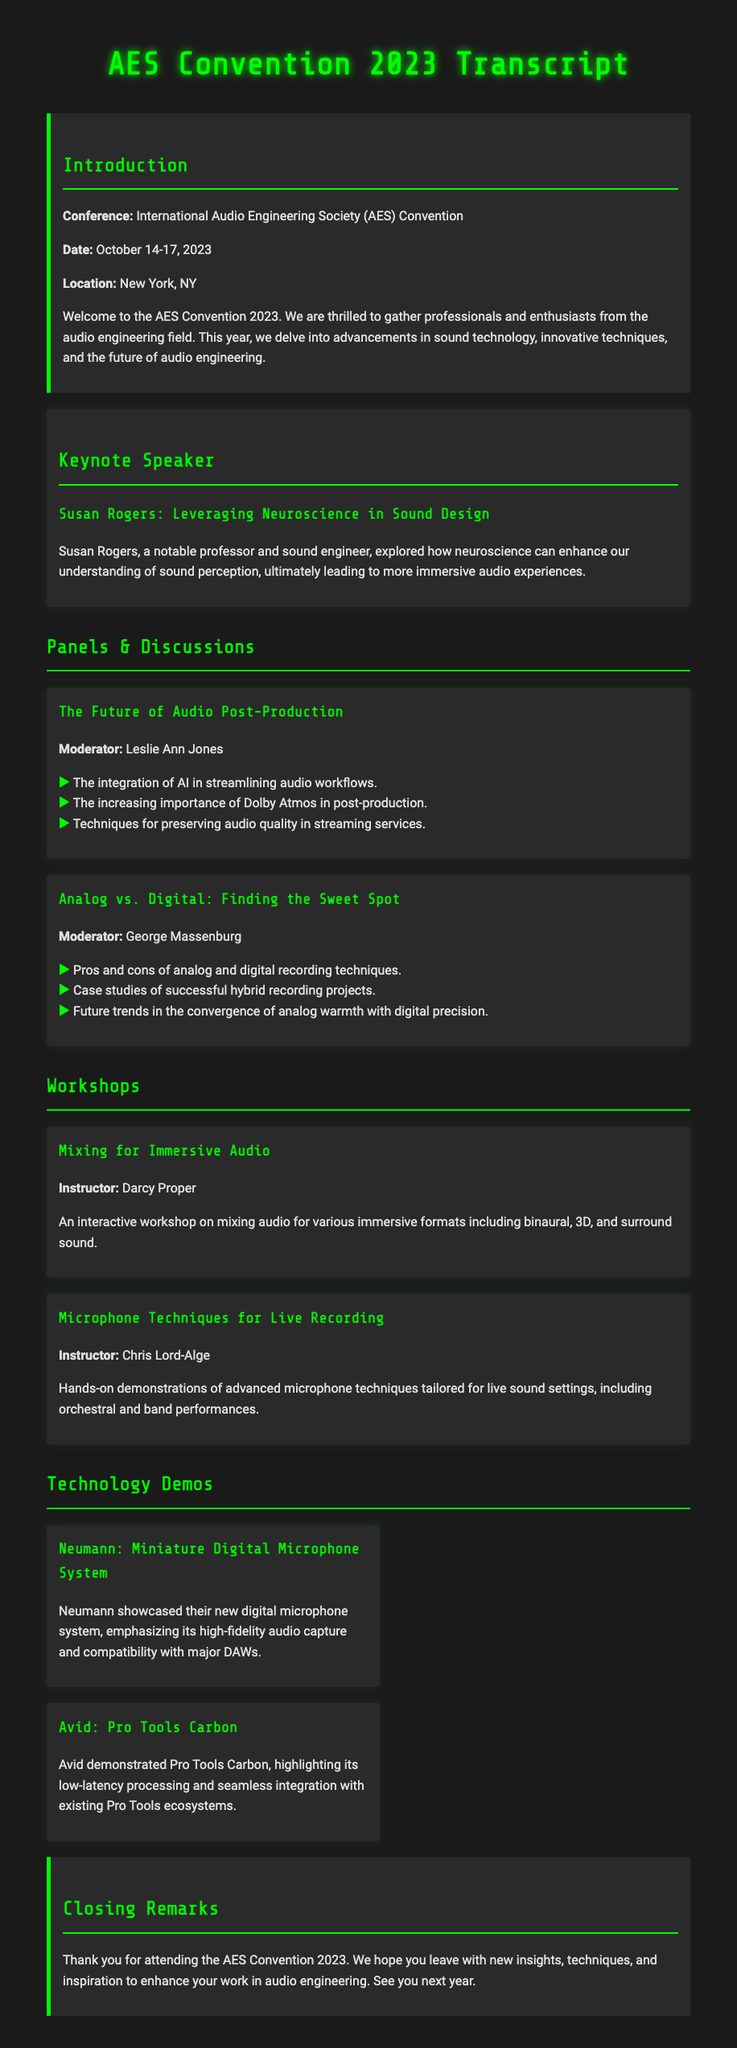What is the name of the keynote speaker? The document mentions Susan Rogers as the keynote speaker at the convention.
Answer: Susan Rogers What were the dates of the AES Convention 2023? The document states that the conference took place from October 14 to October 17, 2023.
Answer: October 14-17, 2023 What topic did Susan Rogers explore? The document specifies that she explored leveraging neuroscience in sound design.
Answer: Neuroscience in sound design Who moderated the panel on the Future of Audio Post-Production? The moderator for that panel is listed as Leslie Ann Jones in the document.
Answer: Leslie Ann Jones What technology did Neumann showcase? Neumann's demo focused on their miniature digital microphone system as stated in the document.
Answer: Miniature Digital Microphone System Which workshop was focused on immersive audio? The workshop titled "Mixing for Immersive Audio" is mentioned in the document.
Answer: Mixing for Immersive Audio What technique did Chris Lord-Alge demonstrate? The document states that he demonstrated advanced microphone techniques tailored for live sound settings.
Answer: Advanced microphone techniques What was the closing remark's sentiment? The closing remarks expressed gratitude for attendance and hopes for new insights, as noted in the document.
Answer: Gratitude for attendance What city hosted the AES Convention 2023? The location of the convention is mentioned as New York, NY in the document.
Answer: New York, NY 